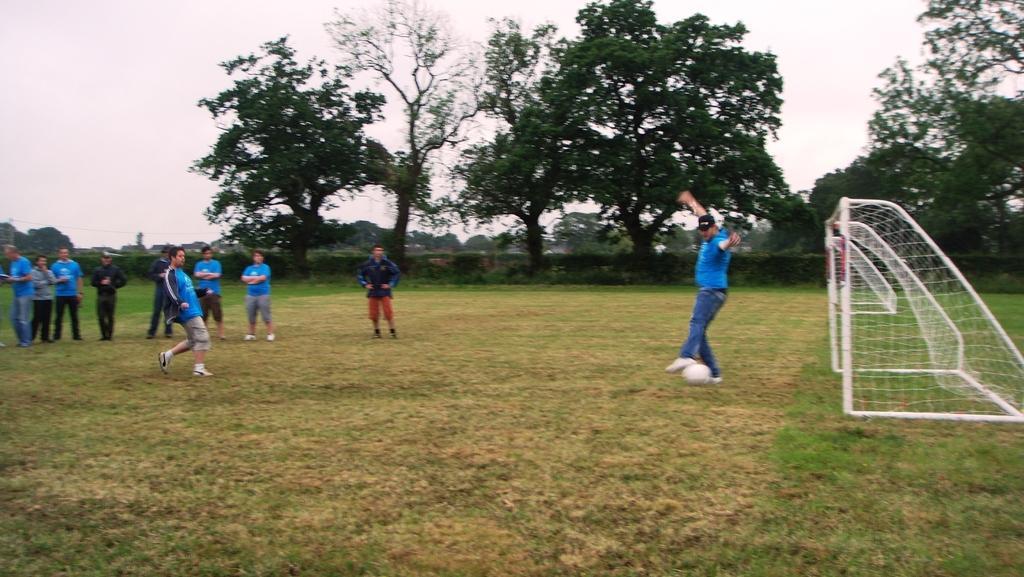Please provide a concise description of this image. In this image there are people playing football on a grassland, in the background there are trees and the sky. 